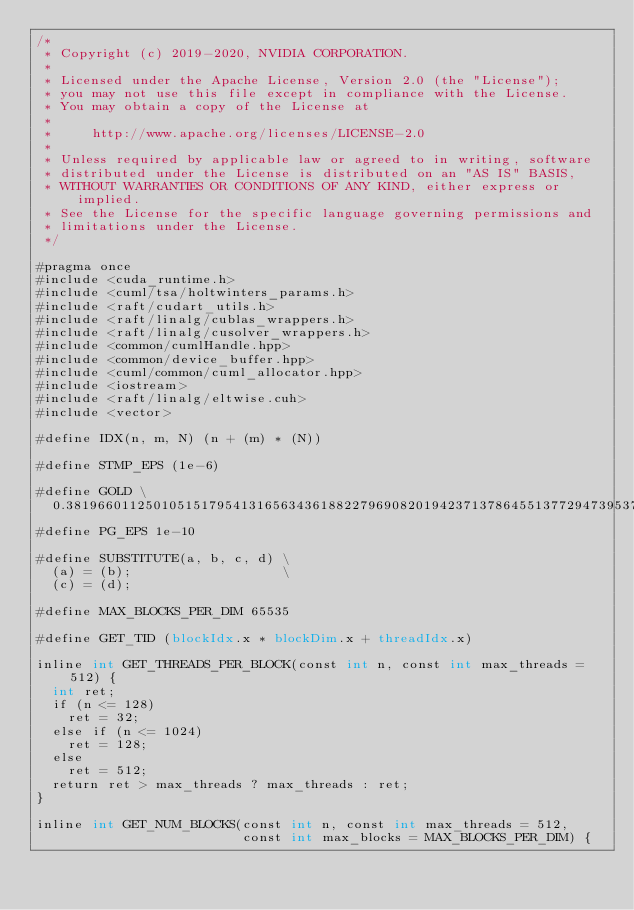Convert code to text. <code><loc_0><loc_0><loc_500><loc_500><_Cuda_>/*
 * Copyright (c) 2019-2020, NVIDIA CORPORATION.
 *
 * Licensed under the Apache License, Version 2.0 (the "License");
 * you may not use this file except in compliance with the License.
 * You may obtain a copy of the License at
 *
 *     http://www.apache.org/licenses/LICENSE-2.0
 *
 * Unless required by applicable law or agreed to in writing, software
 * distributed under the License is distributed on an "AS IS" BASIS,
 * WITHOUT WARRANTIES OR CONDITIONS OF ANY KIND, either express or implied.
 * See the License for the specific language governing permissions and
 * limitations under the License.
 */

#pragma once
#include <cuda_runtime.h>
#include <cuml/tsa/holtwinters_params.h>
#include <raft/cudart_utils.h>
#include <raft/linalg/cublas_wrappers.h>
#include <raft/linalg/cusolver_wrappers.h>
#include <common/cumlHandle.hpp>
#include <common/device_buffer.hpp>
#include <cuml/common/cuml_allocator.hpp>
#include <iostream>
#include <raft/linalg/eltwise.cuh>
#include <vector>

#define IDX(n, m, N) (n + (m) * (N))

#define STMP_EPS (1e-6)

#define GOLD \
  0.381966011250105151795413165634361882279690820194237137864551377294739537181097550292792795810608862515245
#define PG_EPS 1e-10

#define SUBSTITUTE(a, b, c, d) \
  (a) = (b);                   \
  (c) = (d);

#define MAX_BLOCKS_PER_DIM 65535

#define GET_TID (blockIdx.x * blockDim.x + threadIdx.x)

inline int GET_THREADS_PER_BLOCK(const int n, const int max_threads = 512) {
  int ret;
  if (n <= 128)
    ret = 32;
  else if (n <= 1024)
    ret = 128;
  else
    ret = 512;
  return ret > max_threads ? max_threads : ret;
}

inline int GET_NUM_BLOCKS(const int n, const int max_threads = 512,
                          const int max_blocks = MAX_BLOCKS_PER_DIM) {</code> 